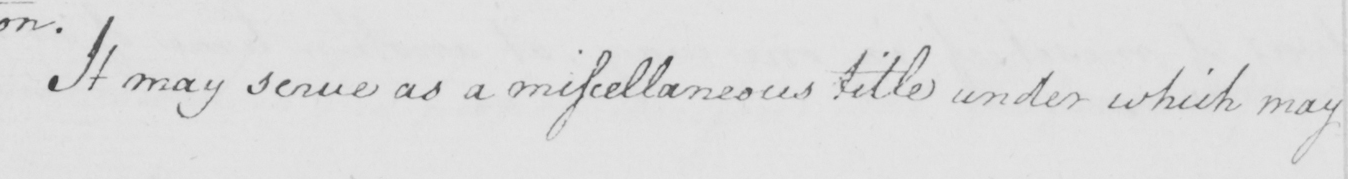What does this handwritten line say? It may serve as a miscellaneous title under which may 